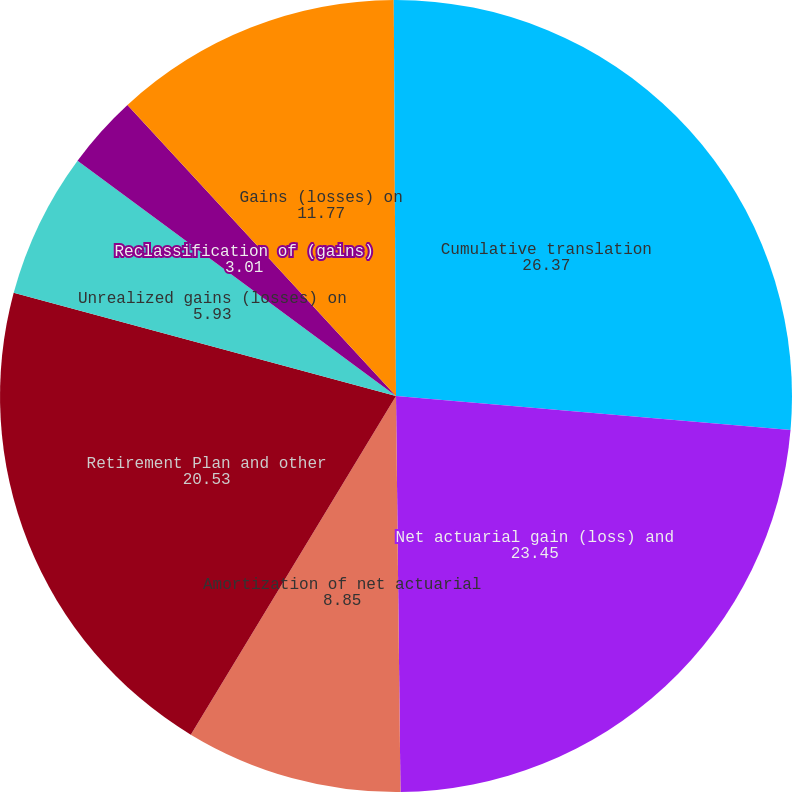<chart> <loc_0><loc_0><loc_500><loc_500><pie_chart><fcel>Cumulative translation<fcel>Net actuarial gain (loss) and<fcel>Amortization of net actuarial<fcel>Retirement Plan and other<fcel>Unrealized gains (losses) on<fcel>Reclassification of (gains)<fcel>Gains (losses) on<fcel>Gains (losses) on cash flow<nl><fcel>26.37%<fcel>23.45%<fcel>8.85%<fcel>20.53%<fcel>5.93%<fcel>3.01%<fcel>11.77%<fcel>0.09%<nl></chart> 